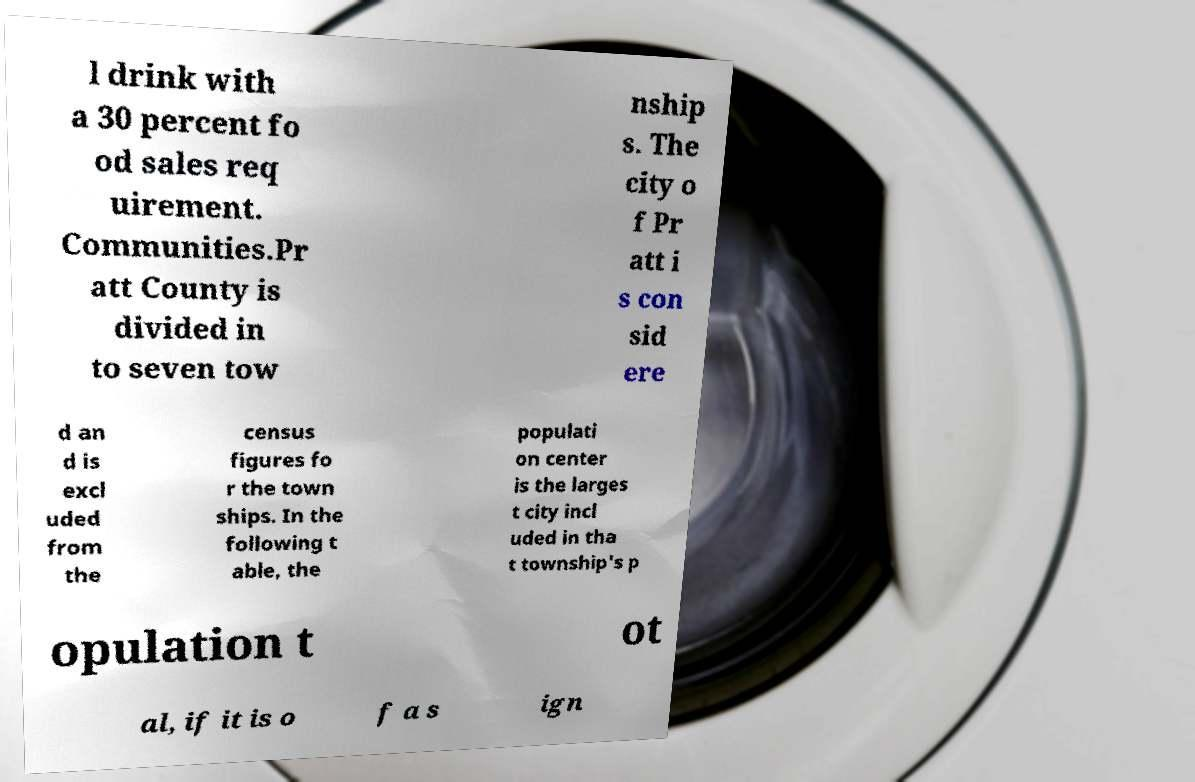There's text embedded in this image that I need extracted. Can you transcribe it verbatim? l drink with a 30 percent fo od sales req uirement. Communities.Pr att County is divided in to seven tow nship s. The city o f Pr att i s con sid ere d an d is excl uded from the census figures fo r the town ships. In the following t able, the populati on center is the larges t city incl uded in tha t township's p opulation t ot al, if it is o f a s ign 